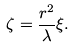Convert formula to latex. <formula><loc_0><loc_0><loc_500><loc_500>\zeta & = \frac { r ^ { 2 } } { \lambda } \xi .</formula> 